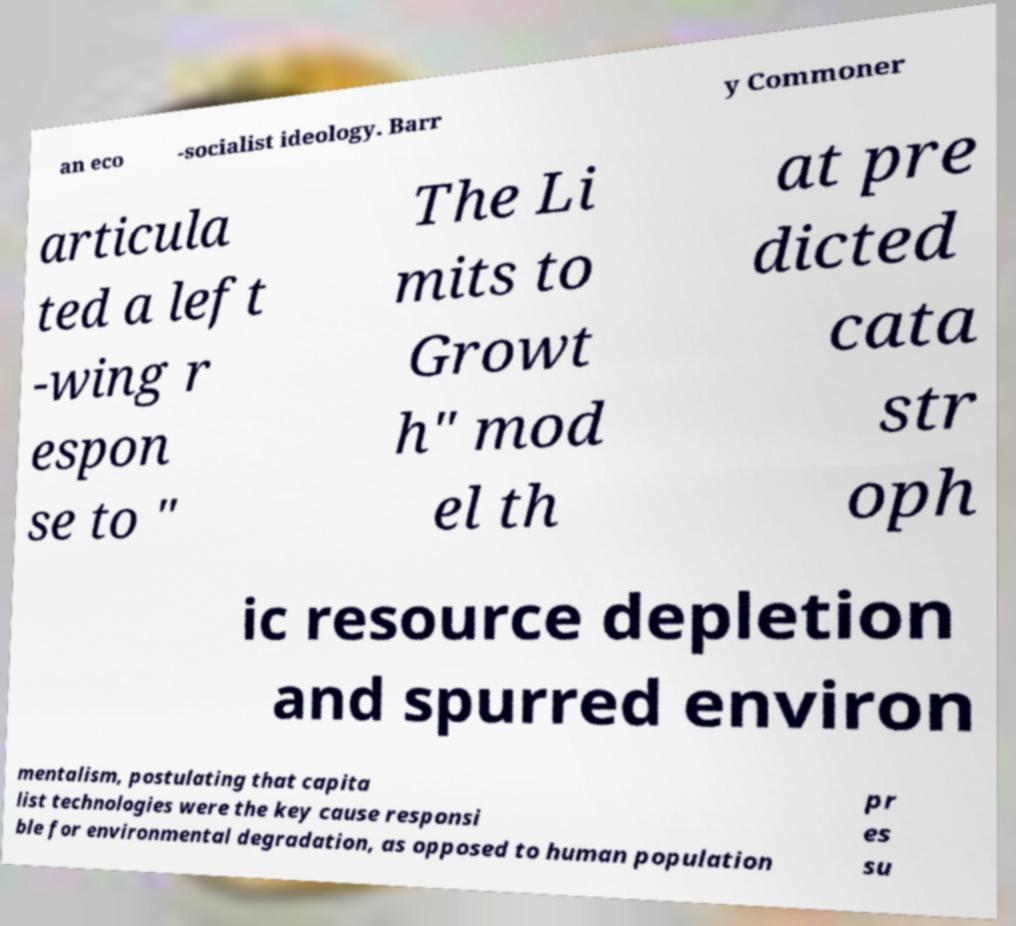Please read and relay the text visible in this image. What does it say? an eco -socialist ideology. Barr y Commoner articula ted a left -wing r espon se to " The Li mits to Growt h" mod el th at pre dicted cata str oph ic resource depletion and spurred environ mentalism, postulating that capita list technologies were the key cause responsi ble for environmental degradation, as opposed to human population pr es su 